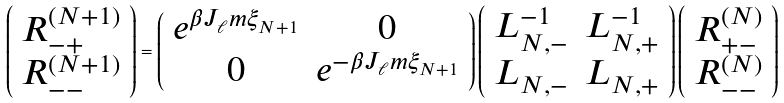<formula> <loc_0><loc_0><loc_500><loc_500>\left ( \begin{array} { c } R ^ { ( N + 1 ) } _ { - + } \\ R ^ { ( N + 1 ) } _ { - - } \end{array} \right ) = \left ( \begin{array} { c c } e ^ { \beta J _ { \ell } m \xi _ { N + 1 } } & 0 \\ 0 & e ^ { - \beta J _ { \ell } m \xi _ { N + 1 } } \end{array} \right ) \left ( \begin{array} { c c } L _ { N , - } ^ { - 1 } & L ^ { - 1 } _ { N , + } \\ L _ { N , - } & L _ { N , + } \end{array} \right ) \left ( \begin{array} { c } R ^ { ( N ) } _ { + - } \\ R ^ { ( N ) } _ { - - } \end{array} \right )</formula> 